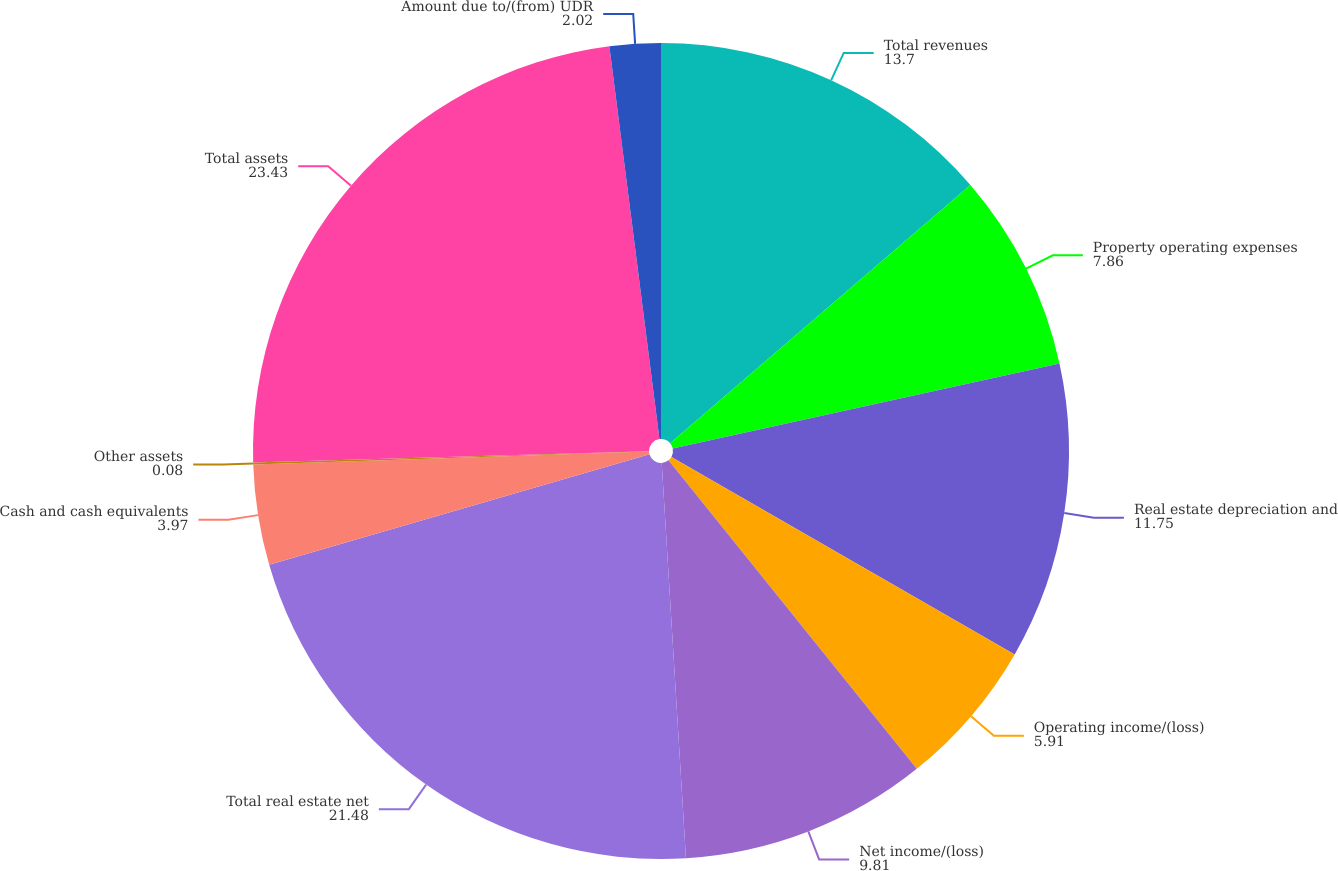Convert chart to OTSL. <chart><loc_0><loc_0><loc_500><loc_500><pie_chart><fcel>Total revenues<fcel>Property operating expenses<fcel>Real estate depreciation and<fcel>Operating income/(loss)<fcel>Net income/(loss)<fcel>Total real estate net<fcel>Cash and cash equivalents<fcel>Other assets<fcel>Total assets<fcel>Amount due to/(from) UDR<nl><fcel>13.7%<fcel>7.86%<fcel>11.75%<fcel>5.91%<fcel>9.81%<fcel>21.48%<fcel>3.97%<fcel>0.08%<fcel>23.43%<fcel>2.02%<nl></chart> 